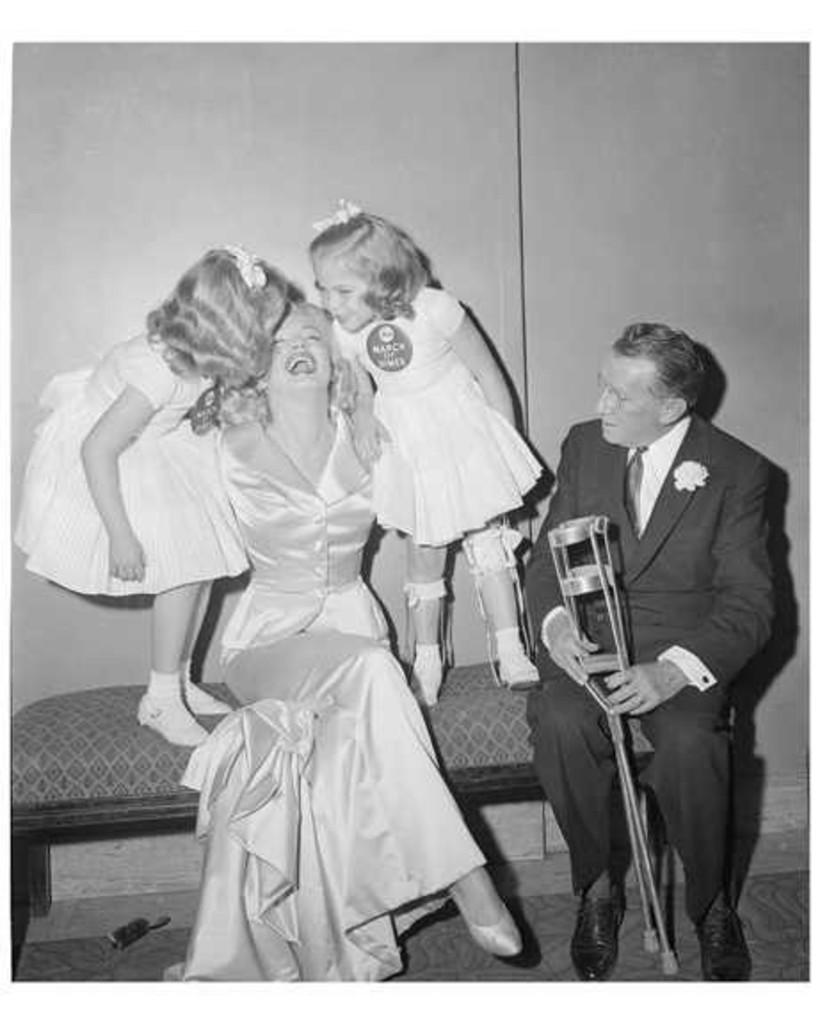What is the color scheme of the image? The image is black and white. How many people are sitting in the image? There are 2 people sitting in the image. How many children are standing in the image? There are 2 children standing in the image. What are the children wearing? The children are wearing white frocks. What type of party is happening in the image? There is no indication of a party in the image; it simply shows 2 people sitting and 2 children standing. Can you tell me if the children are sisters? There is no information about the relationship between the children in the image. 